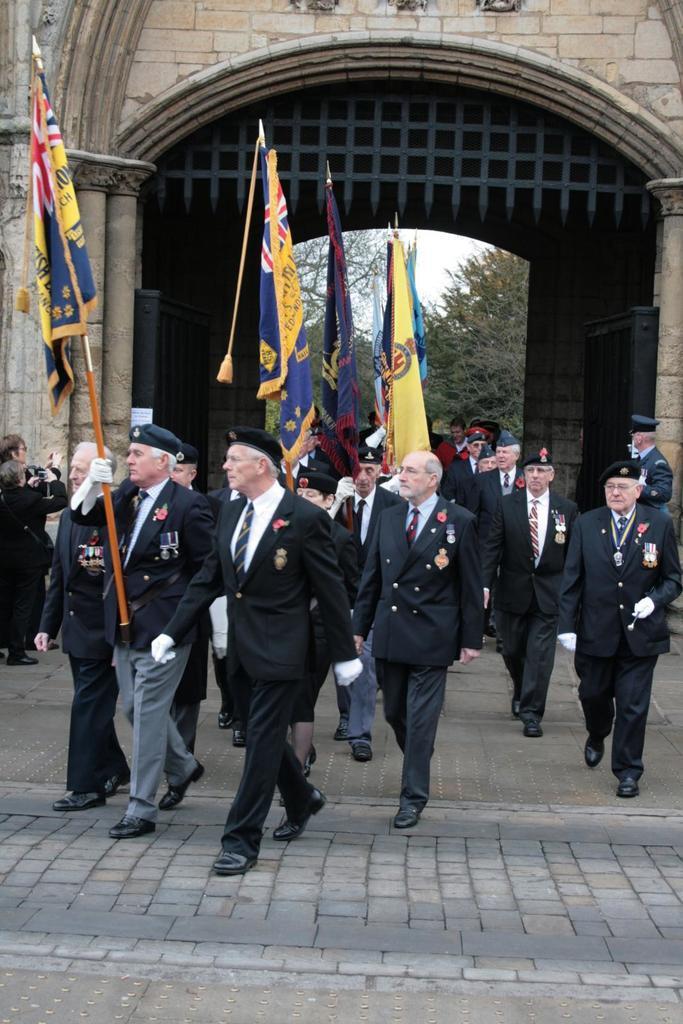How would you summarize this image in a sentence or two? In the center of the picture we can see people walking, few are holding flags. At the bottom it is road. In the background there is an arch. In the center of the background we can see trees. 